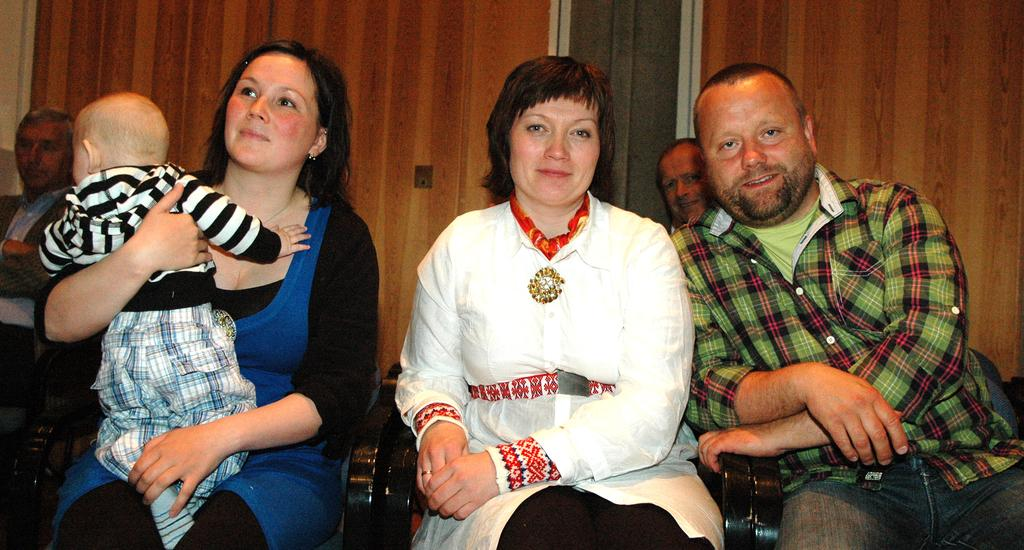What types of people are present in the image? There are men and women in the image. What are the men and women doing in the image? The men and women are sitting on chairs. Are there any children in the image? Yes, there is a child in the image. What type of coast can be seen in the image? There is no coast present in the image; it features men, women, and a child sitting on chairs. What tools might a carpenter use in the image? There is no carpenter or carpentry tools present in the image. 